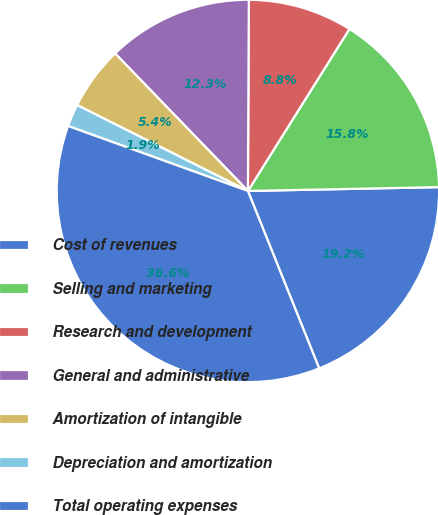Convert chart to OTSL. <chart><loc_0><loc_0><loc_500><loc_500><pie_chart><fcel>Cost of revenues<fcel>Selling and marketing<fcel>Research and development<fcel>General and administrative<fcel>Amortization of intangible<fcel>Depreciation and amortization<fcel>Total operating expenses<nl><fcel>19.24%<fcel>15.77%<fcel>8.83%<fcel>12.3%<fcel>5.36%<fcel>1.9%<fcel>36.59%<nl></chart> 